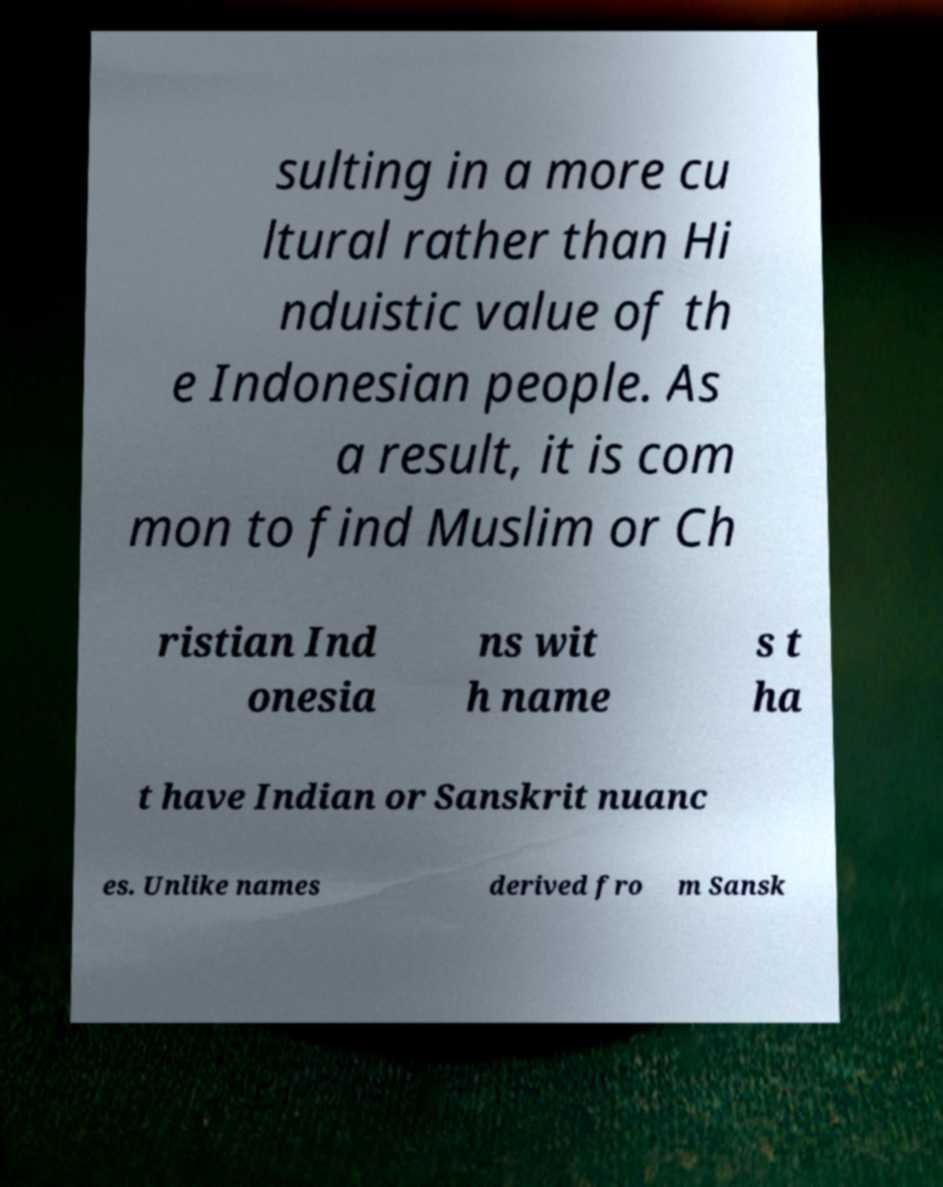What messages or text are displayed in this image? I need them in a readable, typed format. sulting in a more cu ltural rather than Hi nduistic value of th e Indonesian people. As a result, it is com mon to find Muslim or Ch ristian Ind onesia ns wit h name s t ha t have Indian or Sanskrit nuanc es. Unlike names derived fro m Sansk 